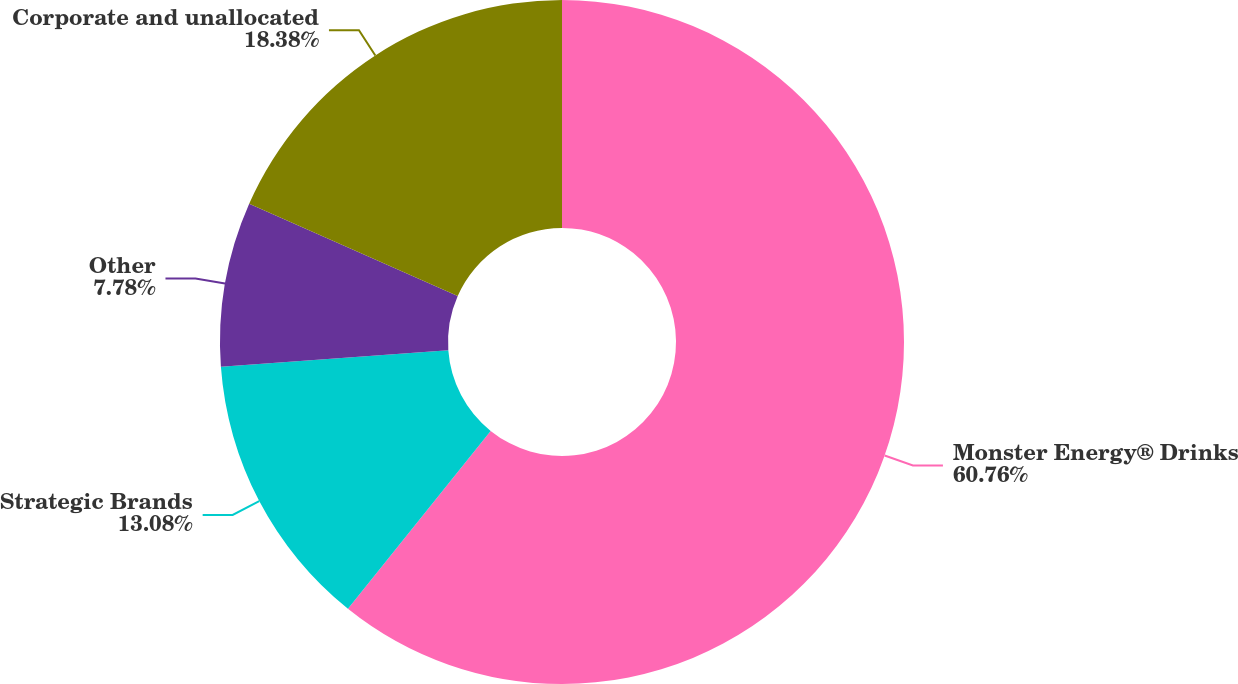Convert chart to OTSL. <chart><loc_0><loc_0><loc_500><loc_500><pie_chart><fcel>Monster Energy® Drinks<fcel>Strategic Brands<fcel>Other<fcel>Corporate and unallocated<nl><fcel>60.77%<fcel>13.08%<fcel>7.78%<fcel>18.38%<nl></chart> 